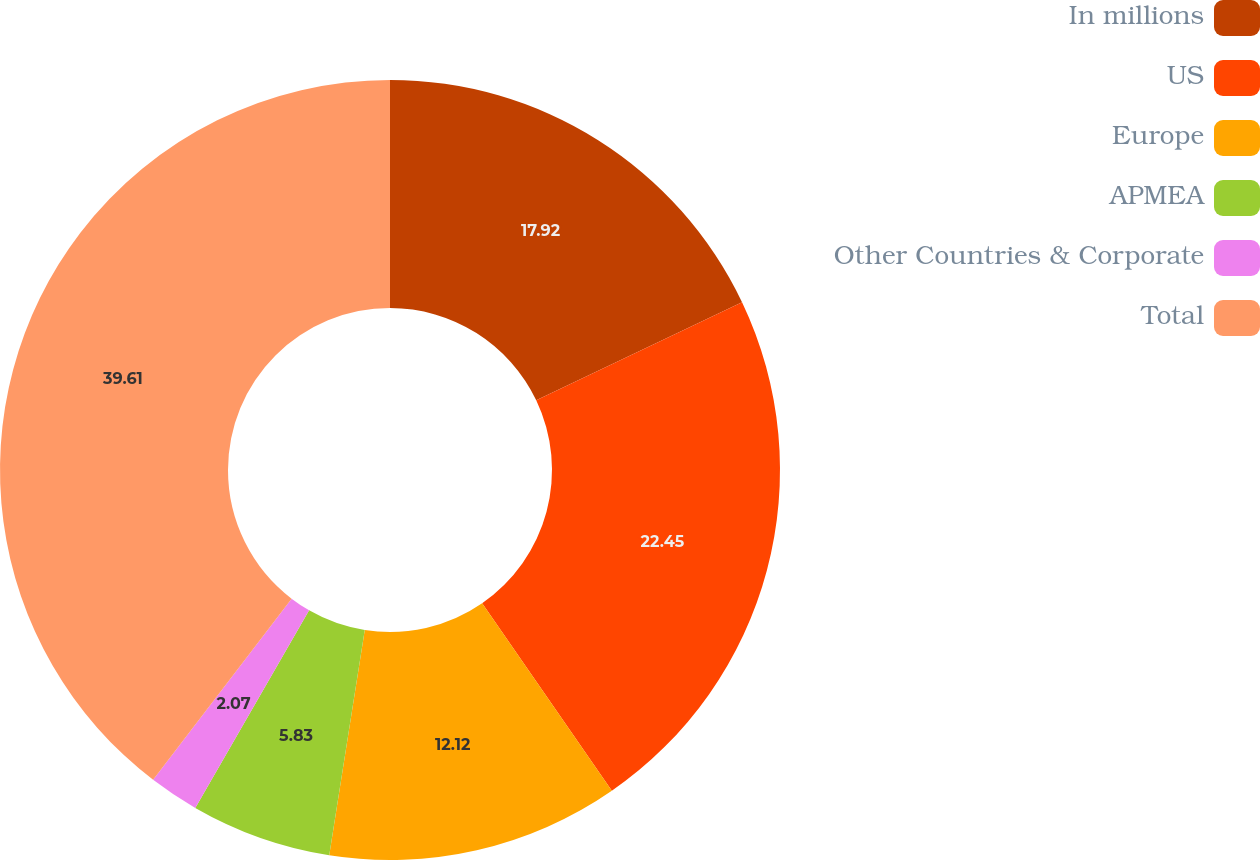Convert chart. <chart><loc_0><loc_0><loc_500><loc_500><pie_chart><fcel>In millions<fcel>US<fcel>Europe<fcel>APMEA<fcel>Other Countries & Corporate<fcel>Total<nl><fcel>17.92%<fcel>22.45%<fcel>12.12%<fcel>5.83%<fcel>2.07%<fcel>39.61%<nl></chart> 